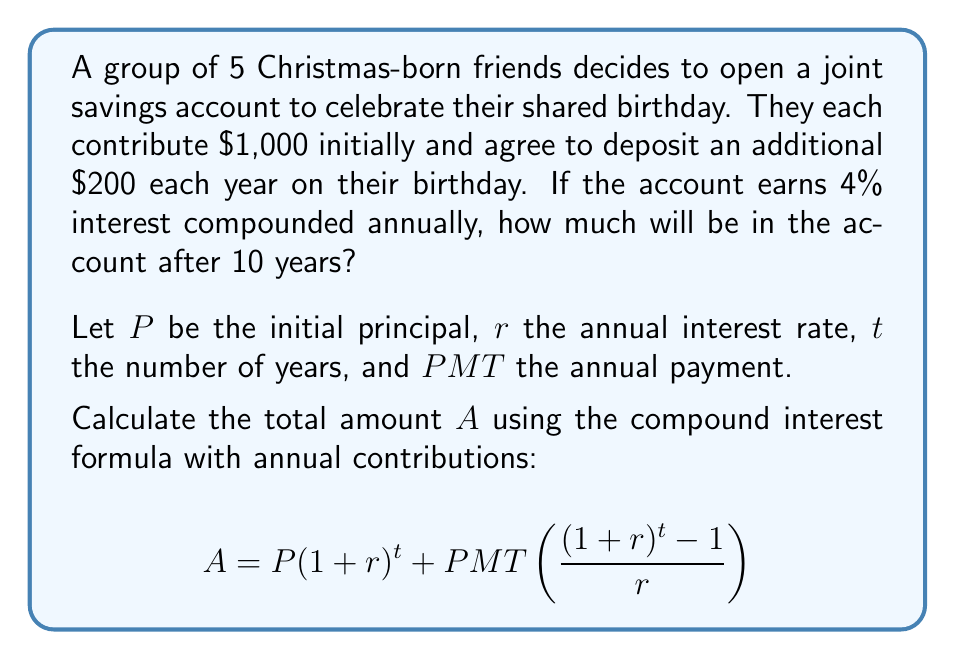Can you answer this question? Let's break this down step-by-step:

1) First, let's identify our variables:
   $P = 5000$ (5 friends × $1000 each)
   $r = 0.04$ (4% annual interest rate)
   $t = 10$ years
   $PMT = 1000$ (5 friends × $200 each per year)

2) Now, let's substitute these values into our formula:

   $$A = 5000(1+0.04)^{10} + 1000\left(\frac{(1+0.04)^{10} - 1}{0.04}\right)$$

3) Let's calculate $(1+0.04)^{10}$ first:
   $(1.04)^{10} \approx 1.4802$

4) Now our equation looks like this:

   $$A = 5000(1.4802) + 1000\left(\frac{1.4802 - 1}{0.04}\right)$$

5) Simplify the first part:
   $5000(1.4802) = 7401$

6) Calculate the fraction in the second part:
   $\frac{1.4802 - 1}{0.04} = \frac{0.4802}{0.04} = 12.005$

7) Our equation is now:
   $$A = 7401 + 1000(12.005)$$

8) Simplify:
   $$A = 7401 + 12005 = 19406$$

Therefore, after 10 years, the account will contain $19,406.
Answer: $19,406 